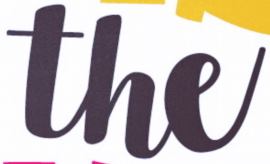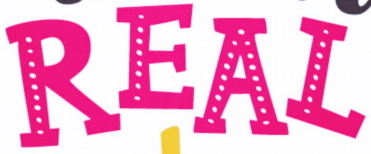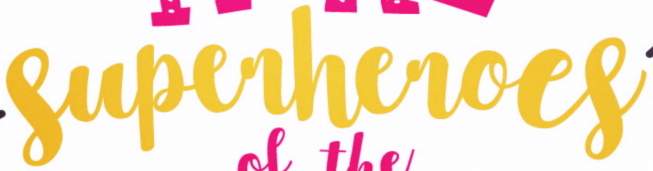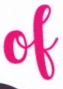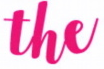What text appears in these images from left to right, separated by a semicolon? the; REAL; superheroes; of; the 